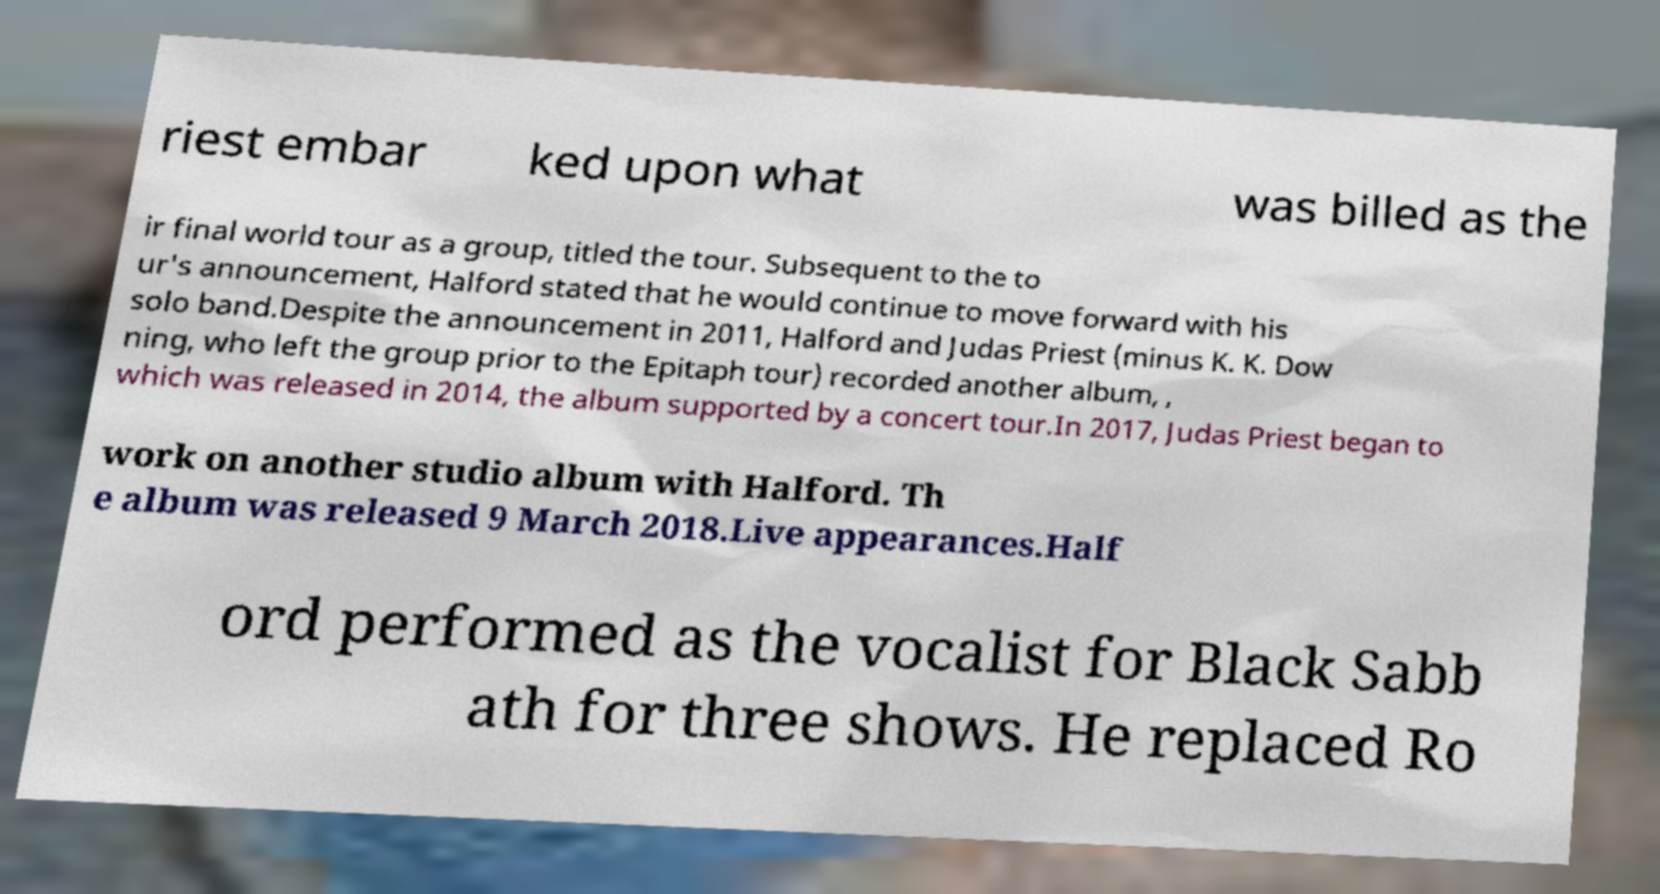What messages or text are displayed in this image? I need them in a readable, typed format. riest embar ked upon what was billed as the ir final world tour as a group, titled the tour. Subsequent to the to ur's announcement, Halford stated that he would continue to move forward with his solo band.Despite the announcement in 2011, Halford and Judas Priest (minus K. K. Dow ning, who left the group prior to the Epitaph tour) recorded another album, , which was released in 2014, the album supported by a concert tour.In 2017, Judas Priest began to work on another studio album with Halford. Th e album was released 9 March 2018.Live appearances.Half ord performed as the vocalist for Black Sabb ath for three shows. He replaced Ro 